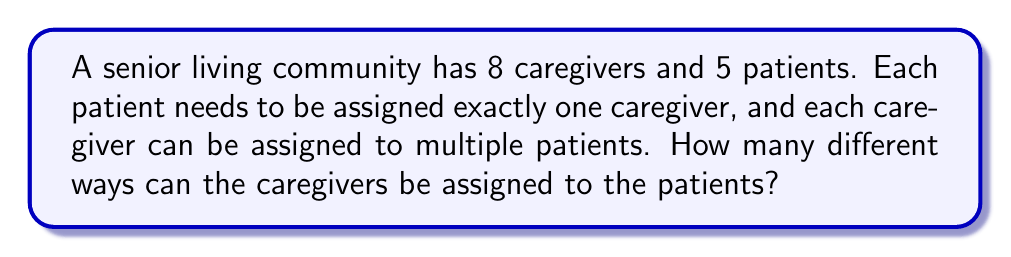Help me with this question. Let's approach this step-by-step:

1) For each patient, we have 8 choices of caregivers.

2) This choice is independent for each patient, meaning the assignment of a caregiver to one patient doesn't affect the choices for other patients.

3) When we have a series of independent choices, we multiply the number of options for each choice.

4) In this case, we're making 5 independent choices (one for each patient), and each choice has 8 options.

5) Therefore, we can use the multiplication principle of counting.

6) The total number of ways to assign caregivers to patients is:

   $$8 \times 8 \times 8 \times 8 \times 8 = 8^5$$

7) We can also write this as:

   $$8^5 = 32,768$$

This result represents all possible combinations of caregiver assignments, allowing for multiple patients to be assigned to the same caregiver.
Answer: $8^5 = 32,768$ 